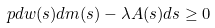<formula> <loc_0><loc_0><loc_500><loc_500>\ p d w ( s ) d m ( s ) - \lambda A ( s ) d s \geq 0</formula> 